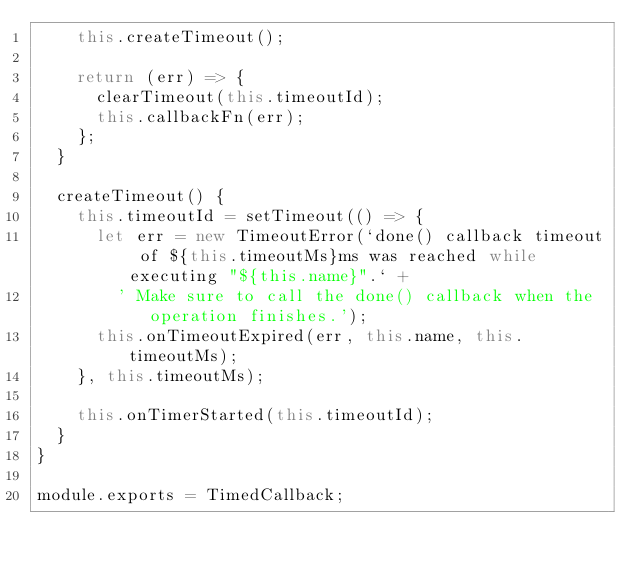<code> <loc_0><loc_0><loc_500><loc_500><_JavaScript_>    this.createTimeout();

    return (err) => {
      clearTimeout(this.timeoutId);
      this.callbackFn(err);
    };
  }

  createTimeout() {
    this.timeoutId = setTimeout(() => {
      let err = new TimeoutError(`done() callback timeout of ${this.timeoutMs}ms was reached while executing "${this.name}".` +
        ' Make sure to call the done() callback when the operation finishes.');
      this.onTimeoutExpired(err, this.name, this.timeoutMs);
    }, this.timeoutMs);

    this.onTimerStarted(this.timeoutId);
  }
}

module.exports = TimedCallback;</code> 